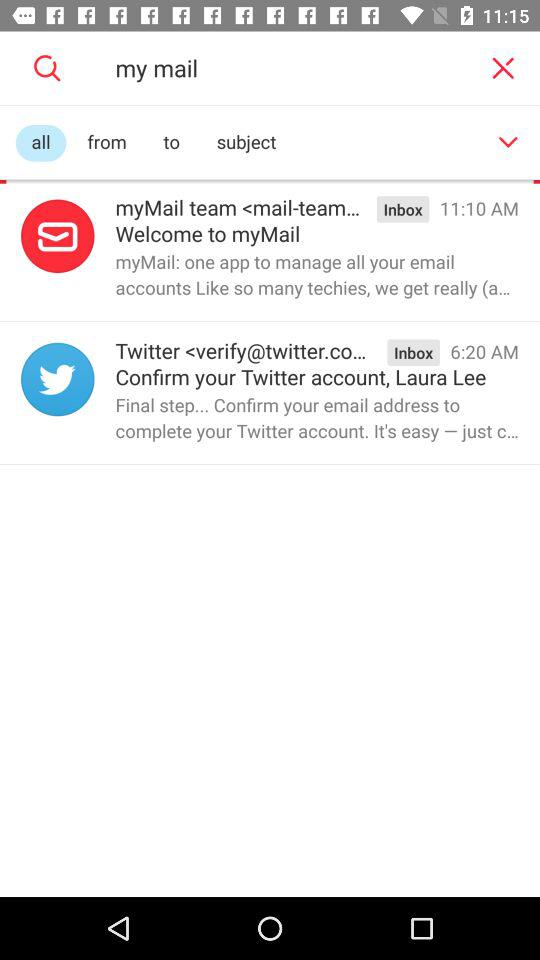How many emails are in the inbox?
Answer the question using a single word or phrase. 2 